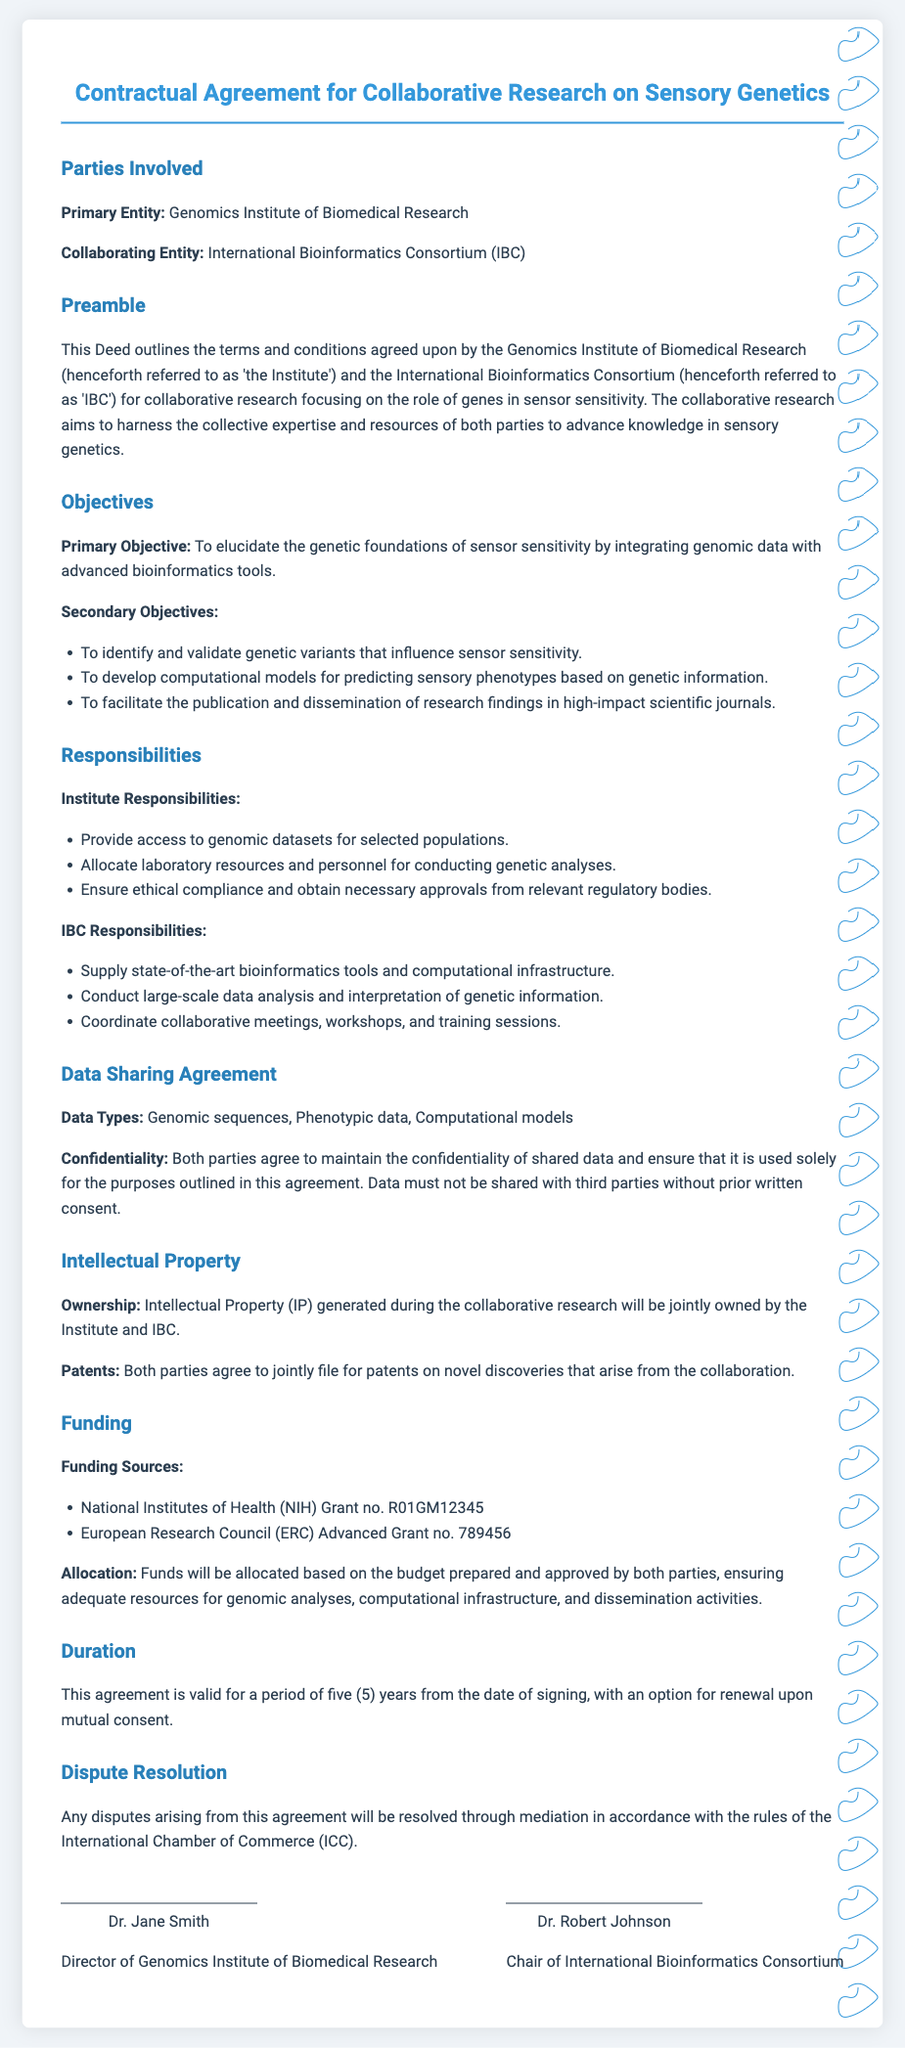what is the primary entity involved in the agreement? The primary entity referred to in the agreement is the Genomics Institute of Biomedical Research.
Answer: Genomics Institute of Biomedical Research who is the collaborating entity? The collaborating entity outlined in the document is the International Bioinformatics Consortium (IBC).
Answer: International Bioinformatics Consortium (IBC) what is the primary objective of the research? The primary objective of the collaborative research is to elucidate the genetic foundations of sensor sensitivity by integrating genomic data with advanced bioinformatics tools.
Answer: To elucidate the genetic foundations of sensor sensitivity how long is the duration of the agreement? The agreement is valid for five years from the date of signing.
Answer: five years which funding source is mentioned first? The first funding source listed in the document is the National Institutes of Health (NIH) Grant no. R01GM12345.
Answer: National Institutes of Health (NIH) Grant no. R01GM12345 what will happen if a dispute arises? Any disputes will be resolved through mediation in accordance with the rules of the International Chamber of Commerce (ICC).
Answer: mediation in accordance with the rules of the International Chamber of Commerce (ICC) who will own the intellectual property generated? Intellectual property generated during the research will be jointly owned by both parties, the Institute and IBC.
Answer: jointly owned by the Institute and IBC what type of data will be shared according to the agreement? The types of data shared include genomic sequences, phenotypic data, and computational models.
Answer: genomic sequences, phenotypic data, computational models what is the option available at the end of the agreement term? At the end of the agreement term, there is an option for renewal upon mutual consent.
Answer: option for renewal upon mutual consent 